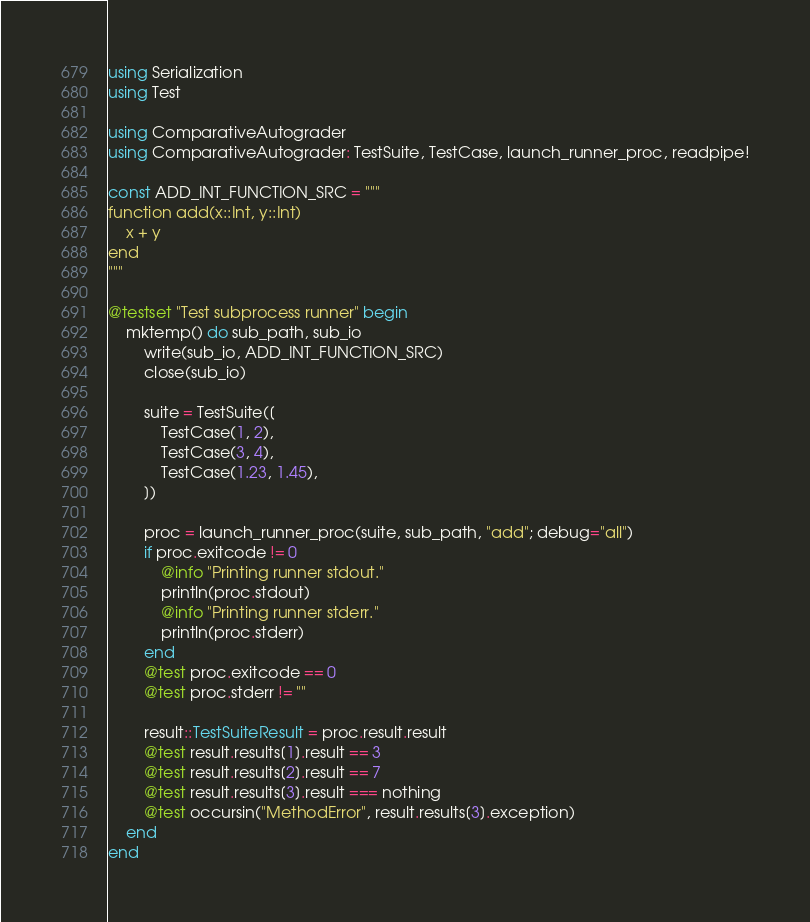Convert code to text. <code><loc_0><loc_0><loc_500><loc_500><_Julia_>using Serialization
using Test

using ComparativeAutograder
using ComparativeAutograder: TestSuite, TestCase, launch_runner_proc, readpipe!

const ADD_INT_FUNCTION_SRC = """
function add(x::Int, y::Int)
    x + y
end
"""

@testset "Test subprocess runner" begin
    mktemp() do sub_path, sub_io
        write(sub_io, ADD_INT_FUNCTION_SRC)
        close(sub_io)

        suite = TestSuite([
            TestCase(1, 2),
            TestCase(3, 4),
            TestCase(1.23, 1.45),
        ])

        proc = launch_runner_proc(suite, sub_path, "add"; debug="all")
        if proc.exitcode != 0
            @info "Printing runner stdout."
            println(proc.stdout)
            @info "Printing runner stderr."
            println(proc.stderr)
        end
        @test proc.exitcode == 0
        @test proc.stderr != ""

        result::TestSuiteResult = proc.result.result
        @test result.results[1].result == 3
        @test result.results[2].result == 7
        @test result.results[3].result === nothing
        @test occursin("MethodError", result.results[3].exception)
    end
end
</code> 